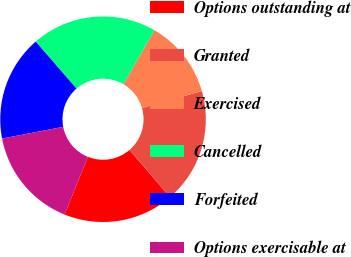<chart> <loc_0><loc_0><loc_500><loc_500><pie_chart><fcel>Options outstanding at<fcel>Granted<fcel>Exercised<fcel>Cancelled<fcel>Forfeited<fcel>Options exercisable at<nl><fcel>17.39%<fcel>18.14%<fcel>12.22%<fcel>19.73%<fcel>16.64%<fcel>15.89%<nl></chart> 